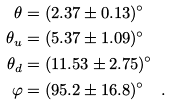Convert formula to latex. <formula><loc_0><loc_0><loc_500><loc_500>\theta & = ( 2 . 3 7 \pm 0 . 1 3 ) ^ { \circ } \\ \theta _ { u } & = ( 5 . 3 7 \pm 1 . 0 9 ) ^ { \circ } \\ \theta _ { d } & = ( 1 1 . 5 3 \pm 2 . 7 5 ) ^ { \circ } \\ \varphi & = ( 9 5 . 2 \pm 1 6 . 8 ) ^ { \circ } \quad .</formula> 